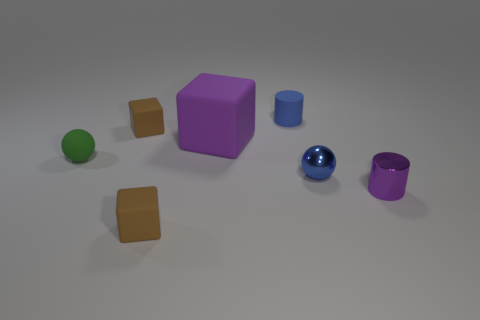Add 2 tiny blue matte balls. How many objects exist? 9 Subtract all brown blocks. How many blocks are left? 1 Subtract all small matte cubes. How many cubes are left? 1 Subtract 1 cylinders. How many cylinders are left? 1 Subtract all cylinders. How many objects are left? 5 Subtract all red balls. Subtract all purple blocks. How many balls are left? 2 Subtract all gray cylinders. How many purple blocks are left? 1 Subtract all purple cylinders. Subtract all green spheres. How many objects are left? 5 Add 1 metal balls. How many metal balls are left? 2 Add 4 cubes. How many cubes exist? 7 